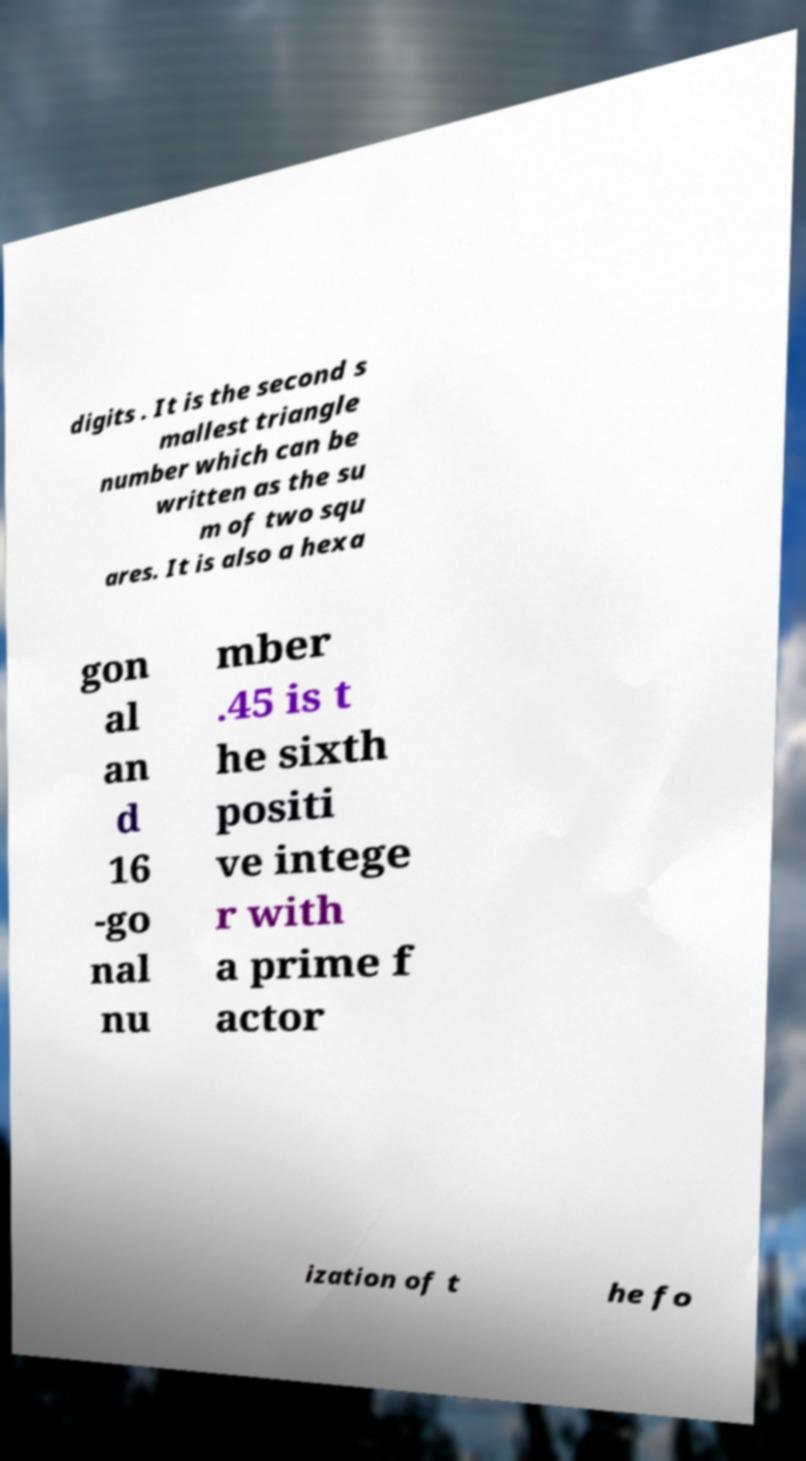For documentation purposes, I need the text within this image transcribed. Could you provide that? digits . It is the second s mallest triangle number which can be written as the su m of two squ ares. It is also a hexa gon al an d 16 -go nal nu mber .45 is t he sixth positi ve intege r with a prime f actor ization of t he fo 